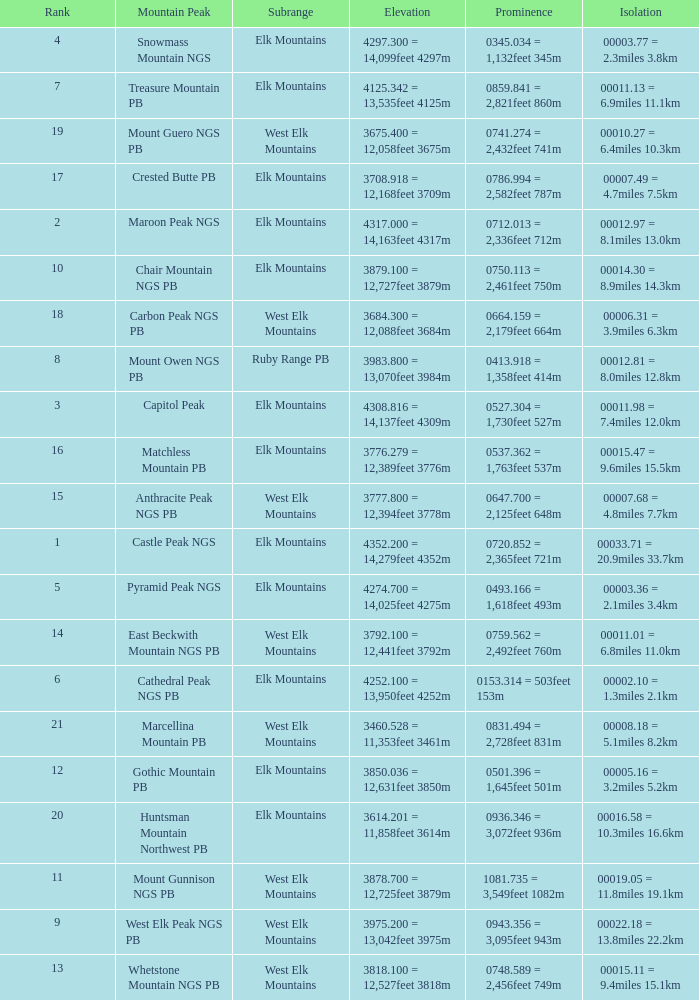Help me parse the entirety of this table. {'header': ['Rank', 'Mountain Peak', 'Subrange', 'Elevation', 'Prominence', 'Isolation'], 'rows': [['4', 'Snowmass Mountain NGS', 'Elk Mountains', '4297.300 = 14,099feet 4297m', '0345.034 = 1,132feet 345m', '00003.77 = 2.3miles 3.8km'], ['7', 'Treasure Mountain PB', 'Elk Mountains', '4125.342 = 13,535feet 4125m', '0859.841 = 2,821feet 860m', '00011.13 = 6.9miles 11.1km'], ['19', 'Mount Guero NGS PB', 'West Elk Mountains', '3675.400 = 12,058feet 3675m', '0741.274 = 2,432feet 741m', '00010.27 = 6.4miles 10.3km'], ['17', 'Crested Butte PB', 'Elk Mountains', '3708.918 = 12,168feet 3709m', '0786.994 = 2,582feet 787m', '00007.49 = 4.7miles 7.5km'], ['2', 'Maroon Peak NGS', 'Elk Mountains', '4317.000 = 14,163feet 4317m', '0712.013 = 2,336feet 712m', '00012.97 = 8.1miles 13.0km'], ['10', 'Chair Mountain NGS PB', 'Elk Mountains', '3879.100 = 12,727feet 3879m', '0750.113 = 2,461feet 750m', '00014.30 = 8.9miles 14.3km'], ['18', 'Carbon Peak NGS PB', 'West Elk Mountains', '3684.300 = 12,088feet 3684m', '0664.159 = 2,179feet 664m', '00006.31 = 3.9miles 6.3km'], ['8', 'Mount Owen NGS PB', 'Ruby Range PB', '3983.800 = 13,070feet 3984m', '0413.918 = 1,358feet 414m', '00012.81 = 8.0miles 12.8km'], ['3', 'Capitol Peak', 'Elk Mountains', '4308.816 = 14,137feet 4309m', '0527.304 = 1,730feet 527m', '00011.98 = 7.4miles 12.0km'], ['16', 'Matchless Mountain PB', 'Elk Mountains', '3776.279 = 12,389feet 3776m', '0537.362 = 1,763feet 537m', '00015.47 = 9.6miles 15.5km'], ['15', 'Anthracite Peak NGS PB', 'West Elk Mountains', '3777.800 = 12,394feet 3778m', '0647.700 = 2,125feet 648m', '00007.68 = 4.8miles 7.7km'], ['1', 'Castle Peak NGS', 'Elk Mountains', '4352.200 = 14,279feet 4352m', '0720.852 = 2,365feet 721m', '00033.71 = 20.9miles 33.7km'], ['5', 'Pyramid Peak NGS', 'Elk Mountains', '4274.700 = 14,025feet 4275m', '0493.166 = 1,618feet 493m', '00003.36 = 2.1miles 3.4km'], ['14', 'East Beckwith Mountain NGS PB', 'West Elk Mountains', '3792.100 = 12,441feet 3792m', '0759.562 = 2,492feet 760m', '00011.01 = 6.8miles 11.0km'], ['6', 'Cathedral Peak NGS PB', 'Elk Mountains', '4252.100 = 13,950feet 4252m', '0153.314 = 503feet 153m', '00002.10 = 1.3miles 2.1km'], ['21', 'Marcellina Mountain PB', 'West Elk Mountains', '3460.528 = 11,353feet 3461m', '0831.494 = 2,728feet 831m', '00008.18 = 5.1miles 8.2km'], ['12', 'Gothic Mountain PB', 'Elk Mountains', '3850.036 = 12,631feet 3850m', '0501.396 = 1,645feet 501m', '00005.16 = 3.2miles 5.2km'], ['20', 'Huntsman Mountain Northwest PB', 'Elk Mountains', '3614.201 = 11,858feet 3614m', '0936.346 = 3,072feet 936m', '00016.58 = 10.3miles 16.6km'], ['11', 'Mount Gunnison NGS PB', 'West Elk Mountains', '3878.700 = 12,725feet 3879m', '1081.735 = 3,549feet 1082m', '00019.05 = 11.8miles 19.1km'], ['9', 'West Elk Peak NGS PB', 'West Elk Mountains', '3975.200 = 13,042feet 3975m', '0943.356 = 3,095feet 943m', '00022.18 = 13.8miles 22.2km'], ['13', 'Whetstone Mountain NGS PB', 'West Elk Mountains', '3818.100 = 12,527feet 3818m', '0748.589 = 2,456feet 749m', '00015.11 = 9.4miles 15.1km']]} Name the Rank of Rank Mountain Peak of crested butte pb? 17.0. 